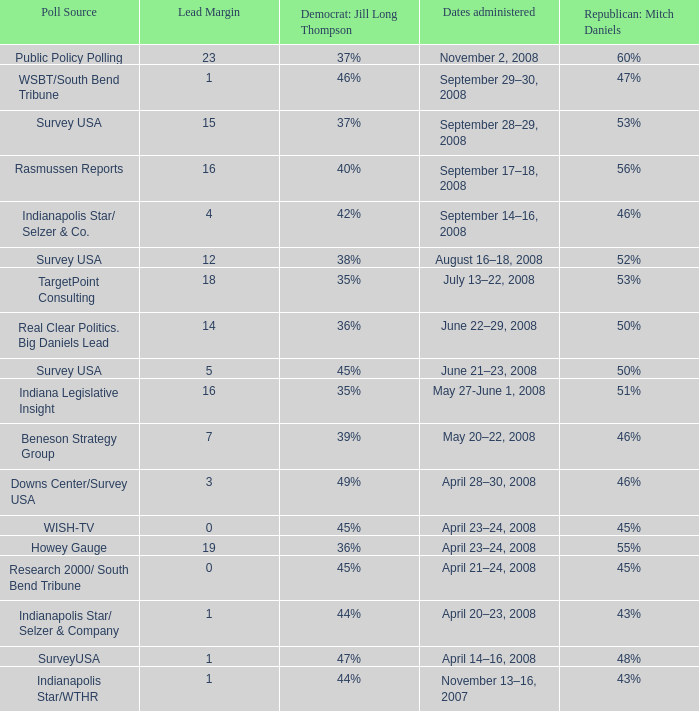What is the lowest Lead Margin when Republican: Mitch Daniels was polling at 48%? 1.0. 